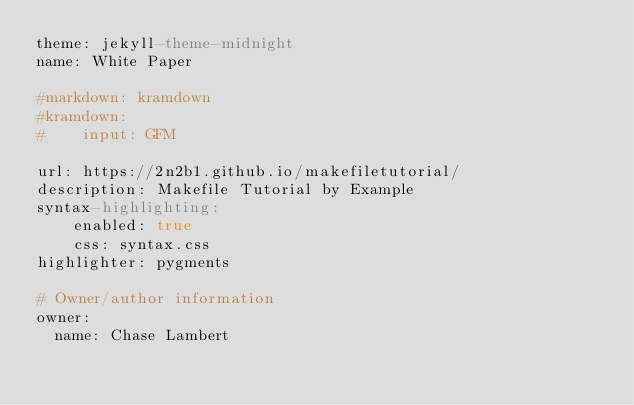<code> <loc_0><loc_0><loc_500><loc_500><_YAML_>theme: jekyll-theme-midnight
name: White Paper

#markdown: kramdown
#kramdown:
#    input: GFM

url: https://2n2b1.github.io/makefiletutorial/
description: Makefile Tutorial by Example
syntax-highlighting:
    enabled: true
    css: syntax.css
highlighter: pygments

# Owner/author information
owner:
  name: Chase Lambert
</code> 